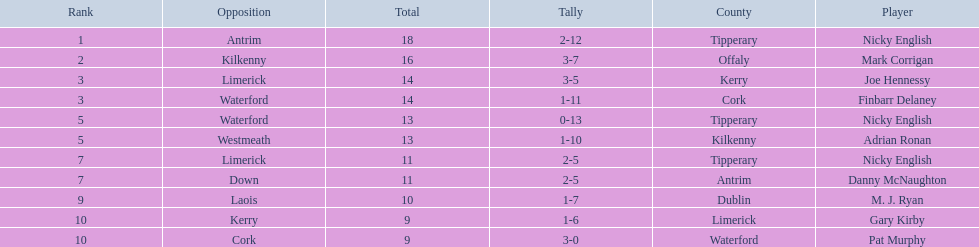Which of the following players were ranked in the bottom 5? Nicky English, Danny McNaughton, M. J. Ryan, Gary Kirby, Pat Murphy. Of these, whose tallies were not 2-5? M. J. Ryan, Gary Kirby, Pat Murphy. From the above three, which one scored more than 9 total points? M. J. Ryan. 